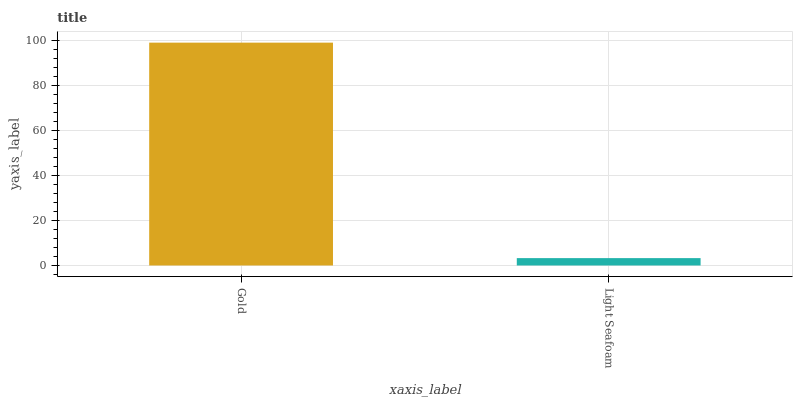Is Light Seafoam the minimum?
Answer yes or no. Yes. Is Gold the maximum?
Answer yes or no. Yes. Is Light Seafoam the maximum?
Answer yes or no. No. Is Gold greater than Light Seafoam?
Answer yes or no. Yes. Is Light Seafoam less than Gold?
Answer yes or no. Yes. Is Light Seafoam greater than Gold?
Answer yes or no. No. Is Gold less than Light Seafoam?
Answer yes or no. No. Is Gold the high median?
Answer yes or no. Yes. Is Light Seafoam the low median?
Answer yes or no. Yes. Is Light Seafoam the high median?
Answer yes or no. No. Is Gold the low median?
Answer yes or no. No. 